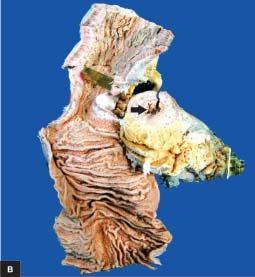what does luminal surface of longitudinal cut section show?
Answer the question using a single word or phrase. Segment of thickened wall with narrow lumen 